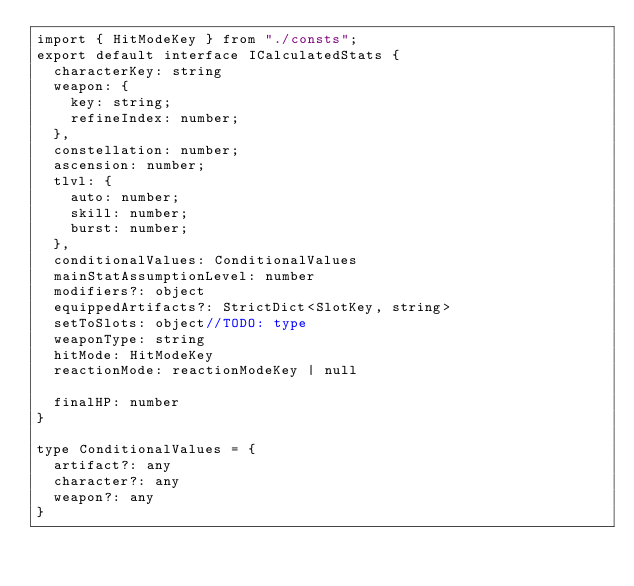<code> <loc_0><loc_0><loc_500><loc_500><_TypeScript_>import { HitModeKey } from "./consts";
export default interface ICalculatedStats {
  characterKey: string
  weapon: {
    key: string;
    refineIndex: number;
  },
  constellation: number;
  ascension: number;
  tlvl: {
    auto: number;
    skill: number;
    burst: number;
  },
  conditionalValues: ConditionalValues
  mainStatAssumptionLevel: number
  modifiers?: object
  equippedArtifacts?: StrictDict<SlotKey, string>
  setToSlots: object//TODO: type
  weaponType: string
  hitMode: HitModeKey
  reactionMode: reactionModeKey | null

  finalHP: number
}

type ConditionalValues = {
  artifact?: any
  character?: any
  weapon?: any
}
</code> 